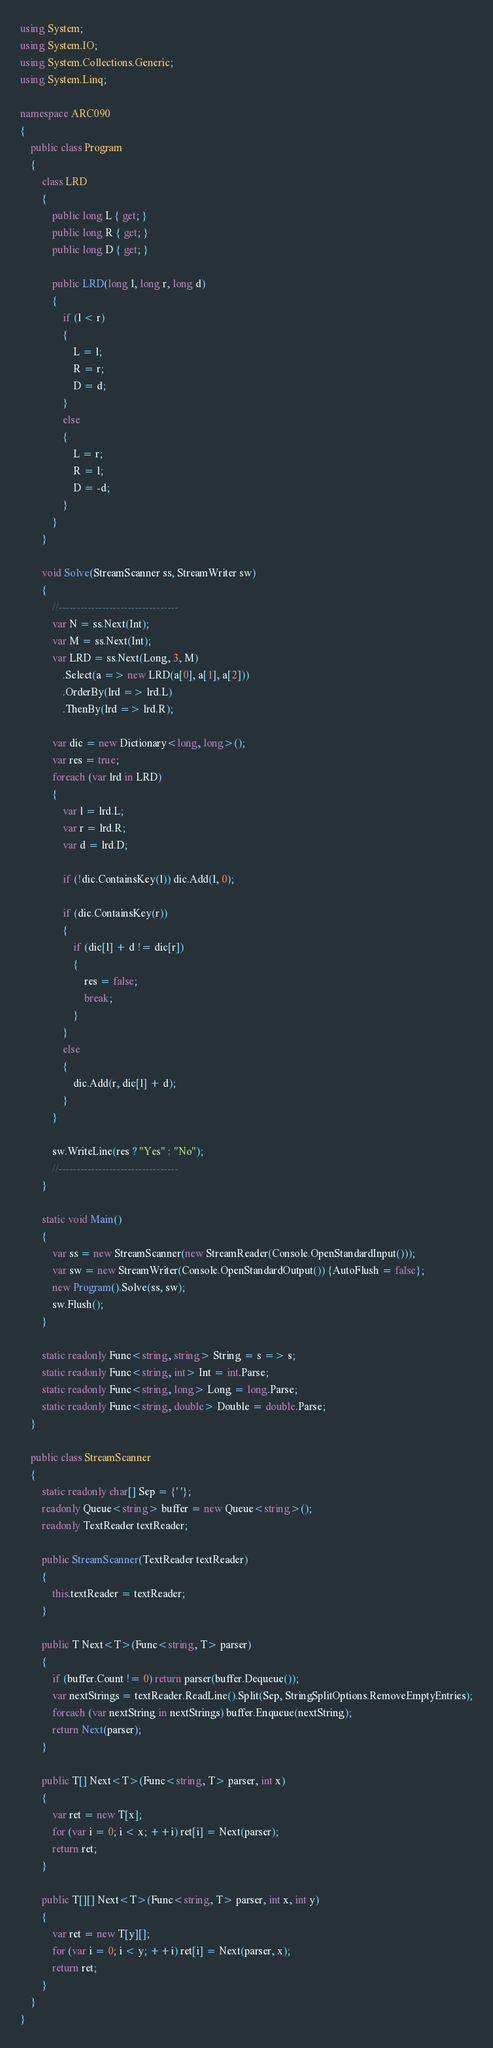<code> <loc_0><loc_0><loc_500><loc_500><_C#_>using System;
using System.IO;
using System.Collections.Generic;
using System.Linq;

namespace ARC090
{
    public class Program
    {
        class LRD
        {
            public long L { get; }
            public long R { get; }
            public long D { get; }

            public LRD(long l, long r, long d)
            {
                if (l < r)
                {
                    L = l;
                    R = r;
                    D = d;
                }
                else
                {
                    L = r;
                    R = l;
                    D = -d;
                }
            }
        }

        void Solve(StreamScanner ss, StreamWriter sw)
        {
            //---------------------------------
            var N = ss.Next(Int);
            var M = ss.Next(Int);
            var LRD = ss.Next(Long, 3, M)
                .Select(a => new LRD(a[0], a[1], a[2]))
                .OrderBy(lrd => lrd.L)
                .ThenBy(lrd => lrd.R);

            var dic = new Dictionary<long, long>();
            var res = true;
            foreach (var lrd in LRD)
            {
                var l = lrd.L;
                var r = lrd.R;
                var d = lrd.D;

                if (!dic.ContainsKey(l)) dic.Add(l, 0);

                if (dic.ContainsKey(r))
                {
                    if (dic[l] + d != dic[r])
                    {
                        res = false;
                        break;
                    }
                }
                else
                {
                    dic.Add(r, dic[l] + d);
                }
            }

            sw.WriteLine(res ? "Yes" : "No");
            //---------------------------------
        }

        static void Main()
        {
            var ss = new StreamScanner(new StreamReader(Console.OpenStandardInput()));
            var sw = new StreamWriter(Console.OpenStandardOutput()) {AutoFlush = false};
            new Program().Solve(ss, sw);
            sw.Flush();
        }

        static readonly Func<string, string> String = s => s;
        static readonly Func<string, int> Int = int.Parse;
        static readonly Func<string, long> Long = long.Parse;
        static readonly Func<string, double> Double = double.Parse;
    }

    public class StreamScanner
    {
        static readonly char[] Sep = {' '};
        readonly Queue<string> buffer = new Queue<string>();
        readonly TextReader textReader;

        public StreamScanner(TextReader textReader)
        {
            this.textReader = textReader;
        }

        public T Next<T>(Func<string, T> parser)
        {
            if (buffer.Count != 0) return parser(buffer.Dequeue());
            var nextStrings = textReader.ReadLine().Split(Sep, StringSplitOptions.RemoveEmptyEntries);
            foreach (var nextString in nextStrings) buffer.Enqueue(nextString);
            return Next(parser);
        }

        public T[] Next<T>(Func<string, T> parser, int x)
        {
            var ret = new T[x];
            for (var i = 0; i < x; ++i) ret[i] = Next(parser);
            return ret;
        }

        public T[][] Next<T>(Func<string, T> parser, int x, int y)
        {
            var ret = new T[y][];
            for (var i = 0; i < y; ++i) ret[i] = Next(parser, x);
            return ret;
        }
    }
}</code> 